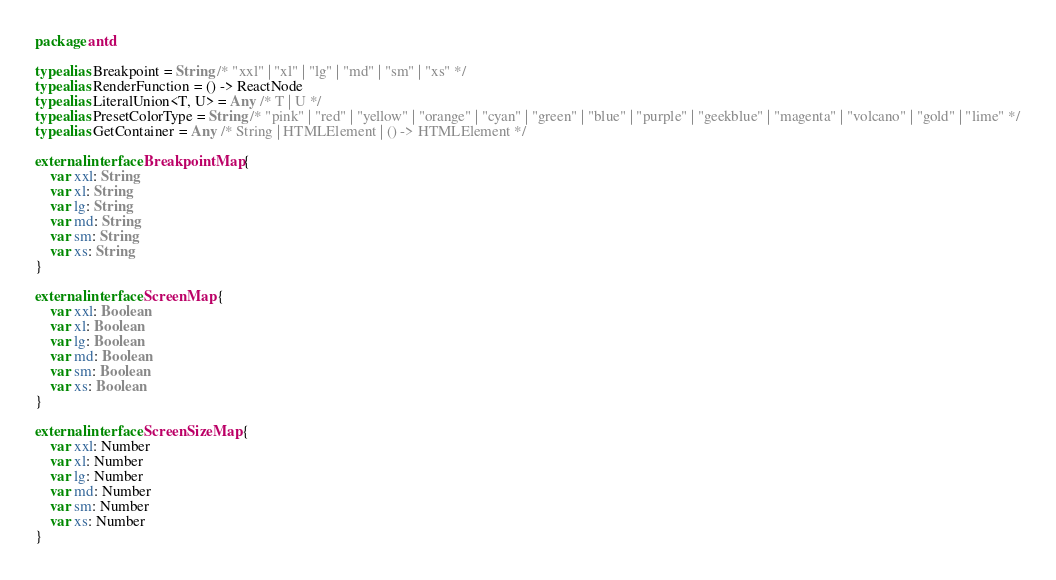Convert code to text. <code><loc_0><loc_0><loc_500><loc_500><_Kotlin_>package antd

typealias Breakpoint = String /* "xxl" | "xl" | "lg" | "md" | "sm" | "xs" */
typealias RenderFunction = () -> ReactNode
typealias LiteralUnion<T, U> = Any /* T | U */
typealias PresetColorType = String /* "pink" | "red" | "yellow" | "orange" | "cyan" | "green" | "blue" | "purple" | "geekblue" | "magenta" | "volcano" | "gold" | "lime" */
typealias GetContainer = Any /* String | HTMLElement | () -> HTMLElement */

external interface BreakpointMap {
    var xxl: String
    var xl: String
    var lg: String
    var md: String
    var sm: String
    var xs: String
}

external interface ScreenMap {
    var xxl: Boolean
    var xl: Boolean
    var lg: Boolean
    var md: Boolean
    var sm: Boolean
    var xs: Boolean
}

external interface ScreenSizeMap {
    var xxl: Number
    var xl: Number
    var lg: Number
    var md: Number
    var sm: Number
    var xs: Number
}
</code> 